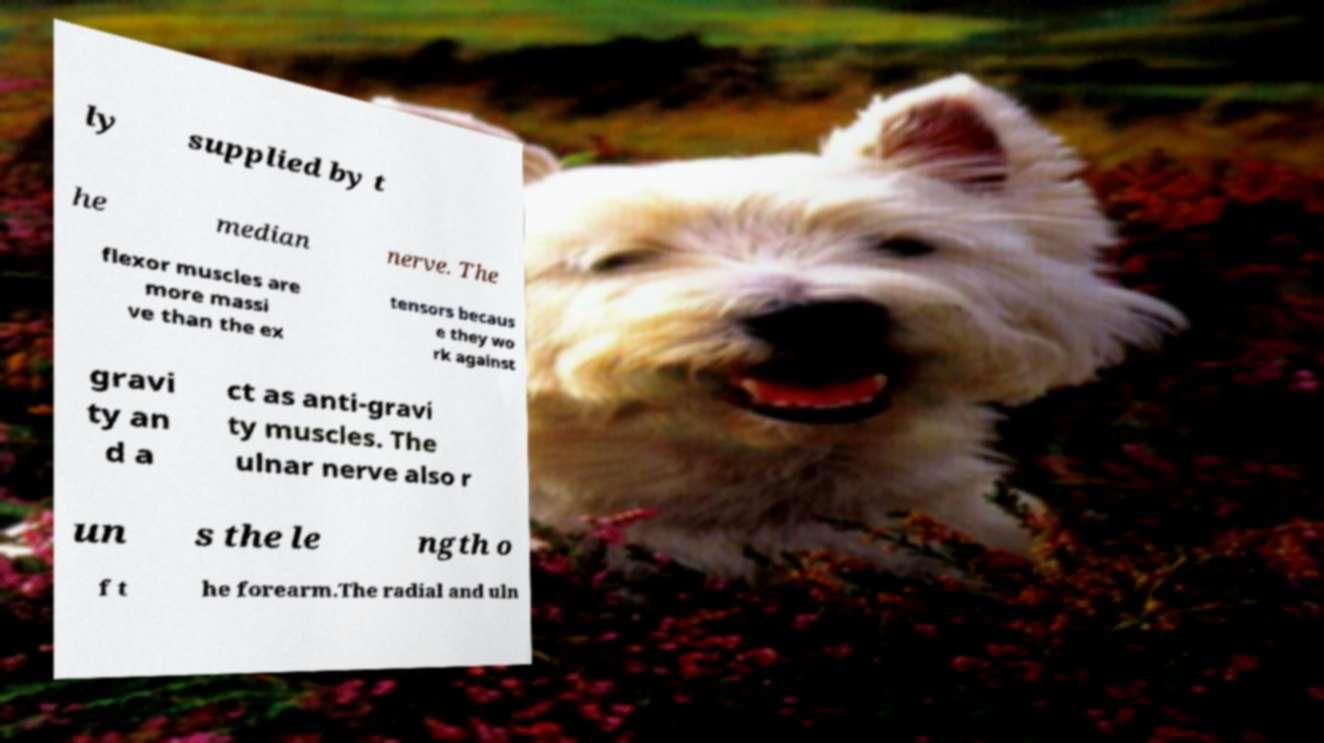What messages or text are displayed in this image? I need them in a readable, typed format. ly supplied by t he median nerve. The flexor muscles are more massi ve than the ex tensors becaus e they wo rk against gravi ty an d a ct as anti-gravi ty muscles. The ulnar nerve also r un s the le ngth o f t he forearm.The radial and uln 